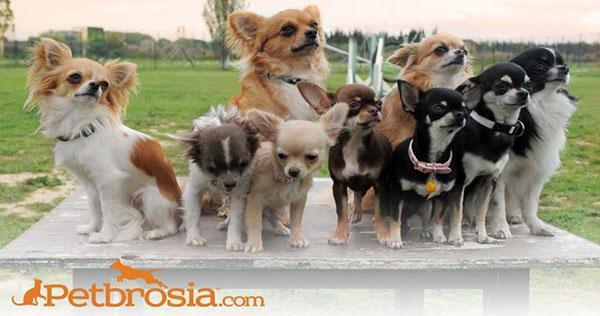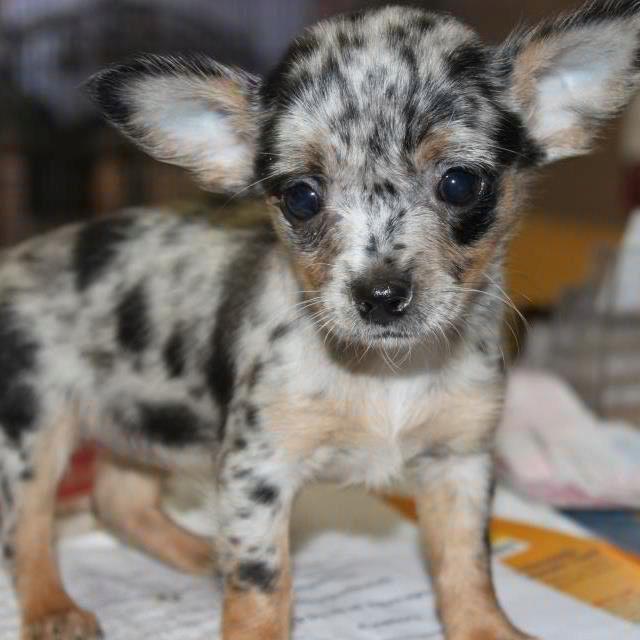The first image is the image on the left, the second image is the image on the right. For the images displayed, is the sentence "Exactly two little dogs are shown, one wearing a collar." factually correct? Answer yes or no. No. The first image is the image on the left, the second image is the image on the right. Evaluate the accuracy of this statement regarding the images: "there are at least five animals in one of the images". Is it true? Answer yes or no. Yes. The first image is the image on the left, the second image is the image on the right. Assess this claim about the two images: "There are two dogs". Correct or not? Answer yes or no. No. The first image is the image on the left, the second image is the image on the right. Assess this claim about the two images: "There are 2 dogs with heads that are at least level.". Correct or not? Answer yes or no. No. 